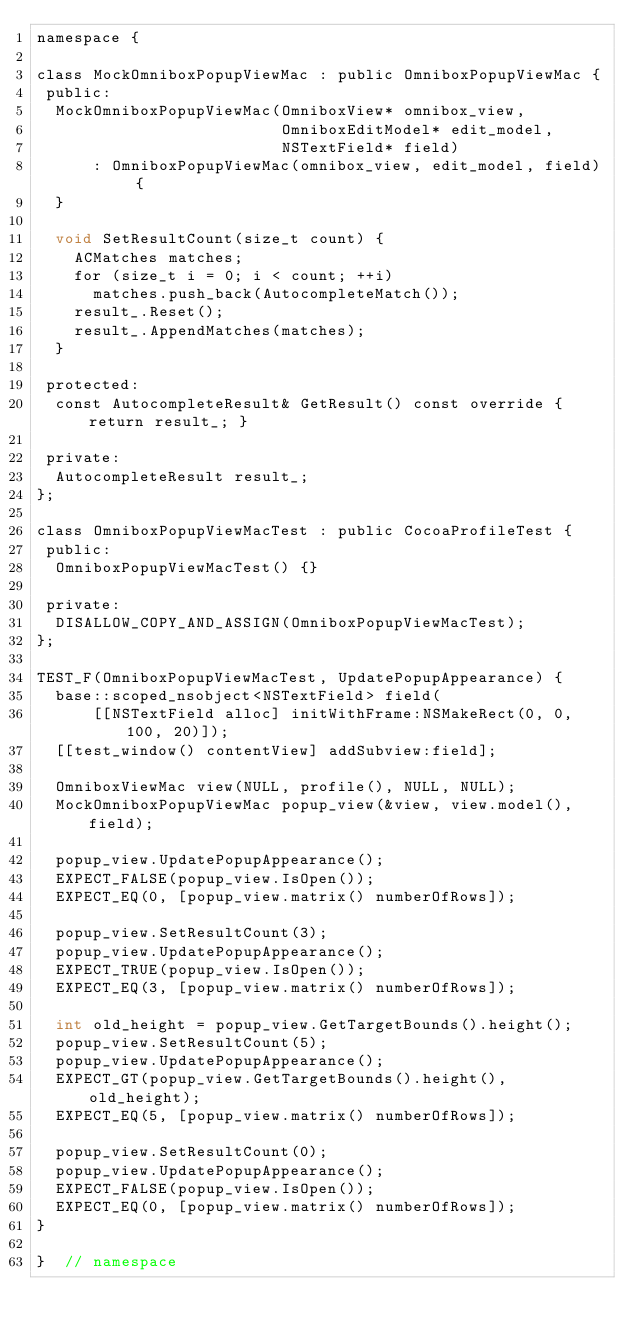Convert code to text. <code><loc_0><loc_0><loc_500><loc_500><_ObjectiveC_>namespace {

class MockOmniboxPopupViewMac : public OmniboxPopupViewMac {
 public:
  MockOmniboxPopupViewMac(OmniboxView* omnibox_view,
                          OmniboxEditModel* edit_model,
                          NSTextField* field)
      : OmniboxPopupViewMac(omnibox_view, edit_model, field) {
  }

  void SetResultCount(size_t count) {
    ACMatches matches;
    for (size_t i = 0; i < count; ++i)
      matches.push_back(AutocompleteMatch());
    result_.Reset();
    result_.AppendMatches(matches);
  }

 protected:
  const AutocompleteResult& GetResult() const override { return result_; }

 private:
  AutocompleteResult result_;
};

class OmniboxPopupViewMacTest : public CocoaProfileTest {
 public:
  OmniboxPopupViewMacTest() {}

 private:
  DISALLOW_COPY_AND_ASSIGN(OmniboxPopupViewMacTest);
};

TEST_F(OmniboxPopupViewMacTest, UpdatePopupAppearance) {
  base::scoped_nsobject<NSTextField> field(
      [[NSTextField alloc] initWithFrame:NSMakeRect(0, 0, 100, 20)]);
  [[test_window() contentView] addSubview:field];

  OmniboxViewMac view(NULL, profile(), NULL, NULL);
  MockOmniboxPopupViewMac popup_view(&view, view.model(), field);

  popup_view.UpdatePopupAppearance();
  EXPECT_FALSE(popup_view.IsOpen());
  EXPECT_EQ(0, [popup_view.matrix() numberOfRows]);

  popup_view.SetResultCount(3);
  popup_view.UpdatePopupAppearance();
  EXPECT_TRUE(popup_view.IsOpen());
  EXPECT_EQ(3, [popup_view.matrix() numberOfRows]);

  int old_height = popup_view.GetTargetBounds().height();
  popup_view.SetResultCount(5);
  popup_view.UpdatePopupAppearance();
  EXPECT_GT(popup_view.GetTargetBounds().height(), old_height);
  EXPECT_EQ(5, [popup_view.matrix() numberOfRows]);

  popup_view.SetResultCount(0);
  popup_view.UpdatePopupAppearance();
  EXPECT_FALSE(popup_view.IsOpen());
  EXPECT_EQ(0, [popup_view.matrix() numberOfRows]);
}

}  // namespace
</code> 